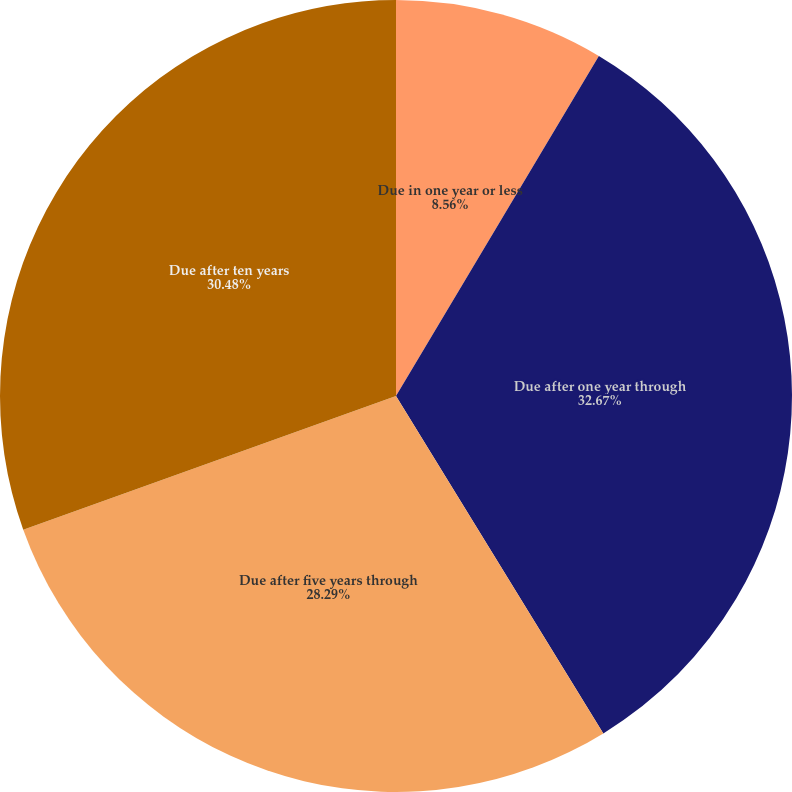<chart> <loc_0><loc_0><loc_500><loc_500><pie_chart><fcel>Due in one year or less<fcel>Due after one year through<fcel>Due after five years through<fcel>Due after ten years<nl><fcel>8.56%<fcel>32.67%<fcel>28.29%<fcel>30.48%<nl></chart> 